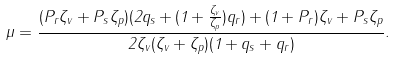Convert formula to latex. <formula><loc_0><loc_0><loc_500><loc_500>\mu = \frac { ( P _ { r } \zeta _ { v } + P _ { s } \zeta _ { p } ) ( 2 q _ { s } + ( 1 + \frac { \zeta _ { v } } { \zeta _ { p } } ) q _ { r } ) + ( 1 + P _ { r } ) \zeta _ { v } + P _ { s } \zeta _ { p } } { 2 \zeta _ { v } ( \zeta _ { v } + \zeta _ { p } ) ( 1 + q _ { s } + q _ { r } ) } .</formula> 